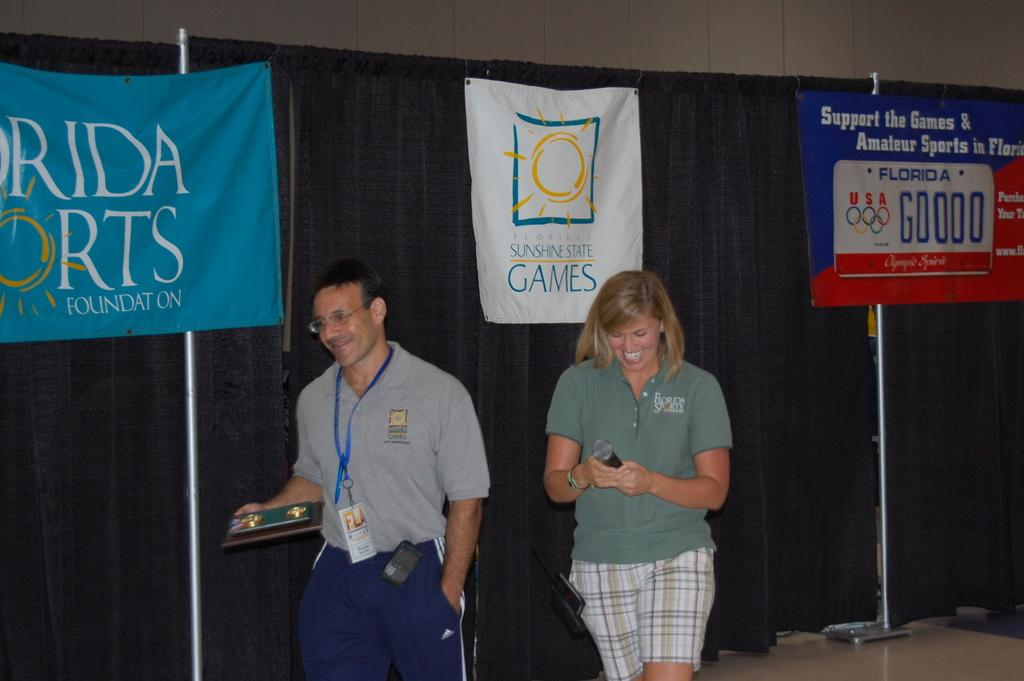How many people are in the image? Two persons are standing at the bottom of the image. What are the people doing in the image? The persons are smiling and holding something in their hands. What can be seen in the background of the image? There is a cloth in the background of the image. What is on the cloth in the image? There are banners on the cloth. What type of pets are visible in the image? There are no pets visible in the image. How is the distribution of the banners on the cloth being managed in the image? The image does not provide information about the distribution of the banners on the cloth. 